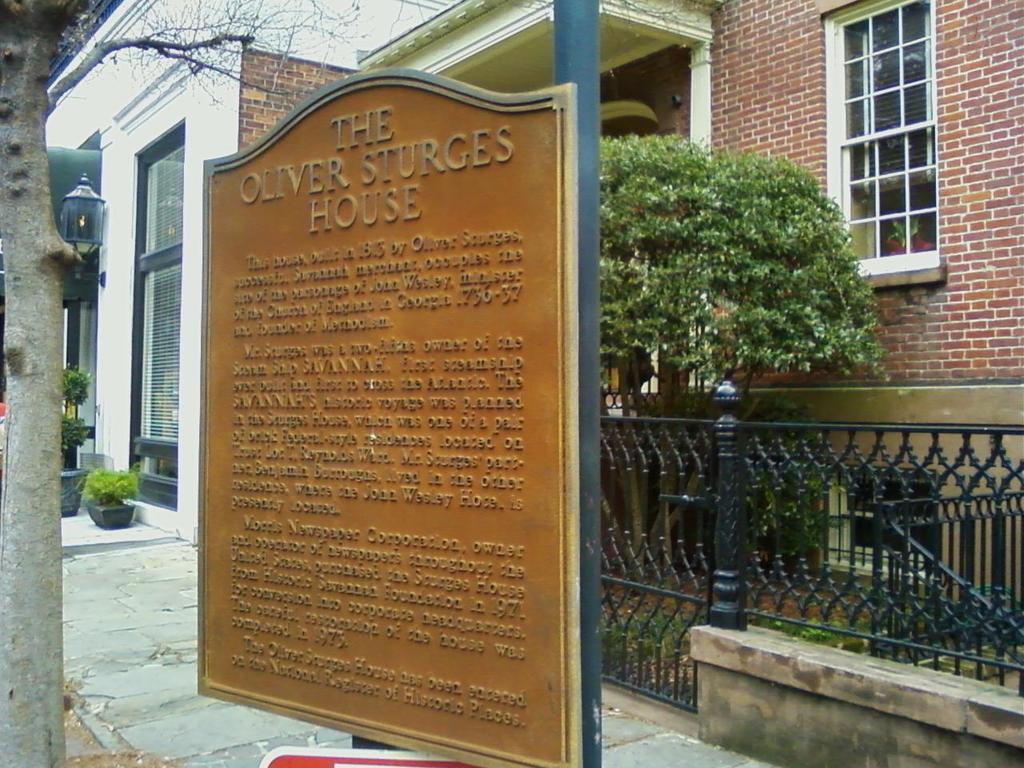What is attached to the pole in the image? There is a board attached to the pole in the image. What can be seen behind the pole? There is a path behind the pole. What type of barrier is present in the image? There is a fence in the image. What type of vegetation is visible in the image? There are trees and plants in the image. What type of structure is present in the image? There is a building in the image. Can you tell me what letter is written on the board attached to the pole? There is no letter written on the board attached to the pole in the image. How much milk is being poured from the building in the image? There is no milk or pouring action depicted in the image. 